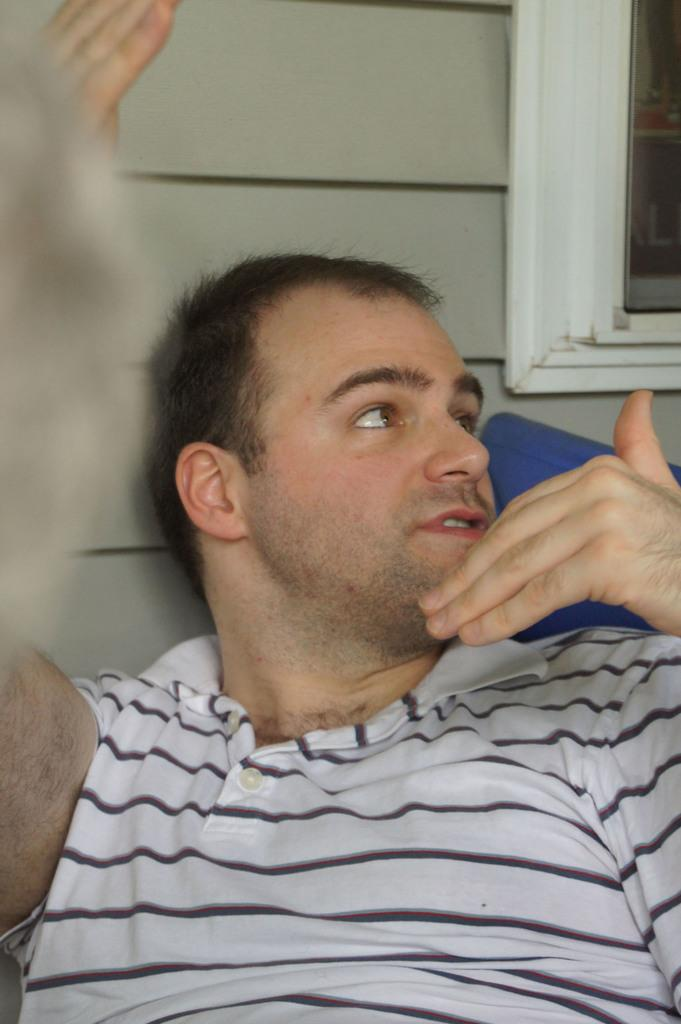What is the person in the image doing? The person is sitting on a chair and speaking. Can you describe the background of the image? There is a window in the background, which is near a wall. What is the person's preferred route to the bucket in the image? There is no bucket present in the image, so it is not possible to determine a preferred route. 